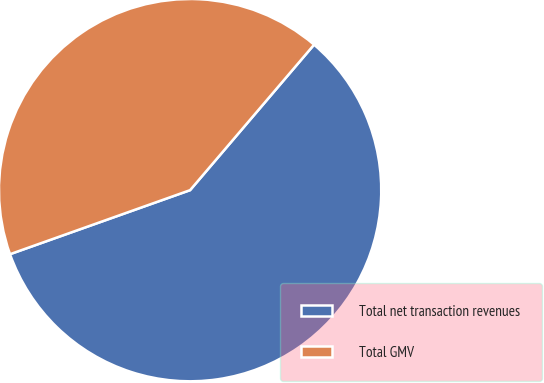Convert chart. <chart><loc_0><loc_0><loc_500><loc_500><pie_chart><fcel>Total net transaction revenues<fcel>Total GMV<nl><fcel>58.33%<fcel>41.67%<nl></chart> 